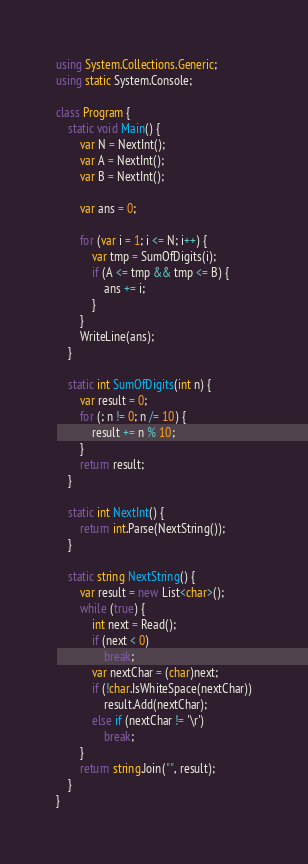Convert code to text. <code><loc_0><loc_0><loc_500><loc_500><_C#_>using System.Collections.Generic;
using static System.Console;

class Program {
	static void Main() {
		var N = NextInt();
		var A = NextInt();
		var B = NextInt();

		var ans = 0;

		for (var i = 1; i <= N; i++) {
			var tmp = SumOfDigits(i);
			if (A <= tmp && tmp <= B) {
				ans += i;
			}
		}
		WriteLine(ans);
	}

	static int SumOfDigits(int n) {
		var result = 0;
		for (; n != 0; n /= 10) {
			result += n % 10;
		}
		return result;
	}

	static int NextInt() {
		return int.Parse(NextString());
	}

	static string NextString() {
		var result = new List<char>();
		while (true) {
			int next = Read();
			if (next < 0)
				break;
			var nextChar = (char)next;
			if (!char.IsWhiteSpace(nextChar))
				result.Add(nextChar);
			else if (nextChar != '\r')
				break;
		}
		return string.Join("", result);
	}
}</code> 